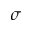<formula> <loc_0><loc_0><loc_500><loc_500>\sigma</formula> 